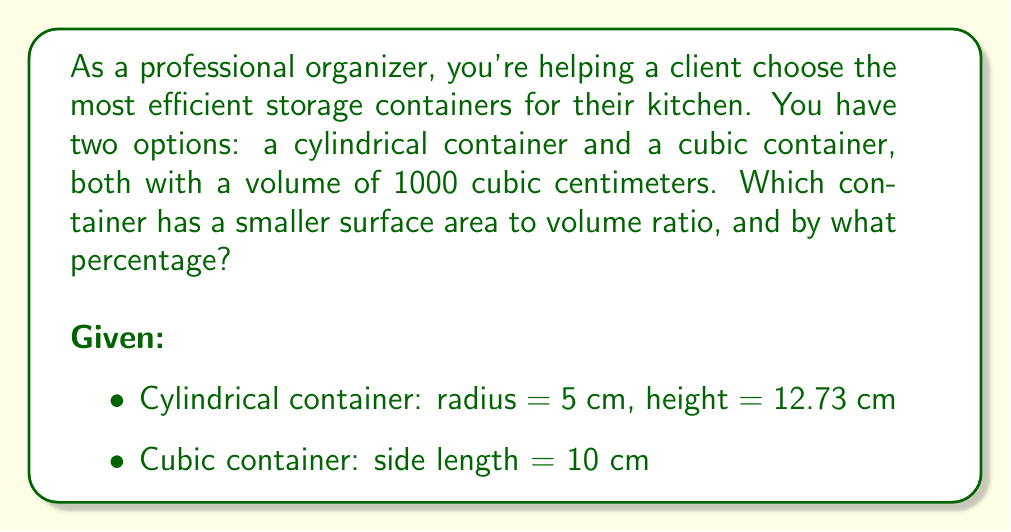Provide a solution to this math problem. To solve this problem, we need to calculate the surface area to volume ratio for both containers and compare them.

1. Cylindrical container:
   Volume: $V_c = \pi r^2 h = 1000 \text{ cm}^3$
   Surface Area: $SA_c = 2\pi r^2 + 2\pi rh$
   
   $SA_c = 2\pi(5\text{ cm})^2 + 2\pi(5\text{ cm})(12.73\text{ cm})$
   $SA_c = 157.08\text{ cm}^2 + 400\text{ cm}^2 = 557.08\text{ cm}^2$
   
   Surface Area to Volume Ratio: $\frac{SA_c}{V_c} = \frac{557.08\text{ cm}^2}{1000\text{ cm}^3} = 0.55708\text{ cm}^{-1}$

2. Cubic container:
   Volume: $V_b = s^3 = 1000 \text{ cm}^3$
   Surface Area: $SA_b = 6s^2 = 6(10\text{ cm})^2 = 600\text{ cm}^2$
   
   Surface Area to Volume Ratio: $\frac{SA_b}{V_b} = \frac{600\text{ cm}^2}{1000\text{ cm}^3} = 0.6\text{ cm}^{-1}$

3. Comparison:
   The cylindrical container has a smaller surface area to volume ratio.
   
   Percentage difference:
   $$\text{Difference} = \frac{0.6 - 0.55708}{0.6} \times 100\% = 7.15\%$$

Therefore, the cylindrical container has a surface area to volume ratio that is 7.15% smaller than the cubic container.
Answer: The cylindrical container has a smaller surface area to volume ratio, which is 7.15% less than the cubic container. 